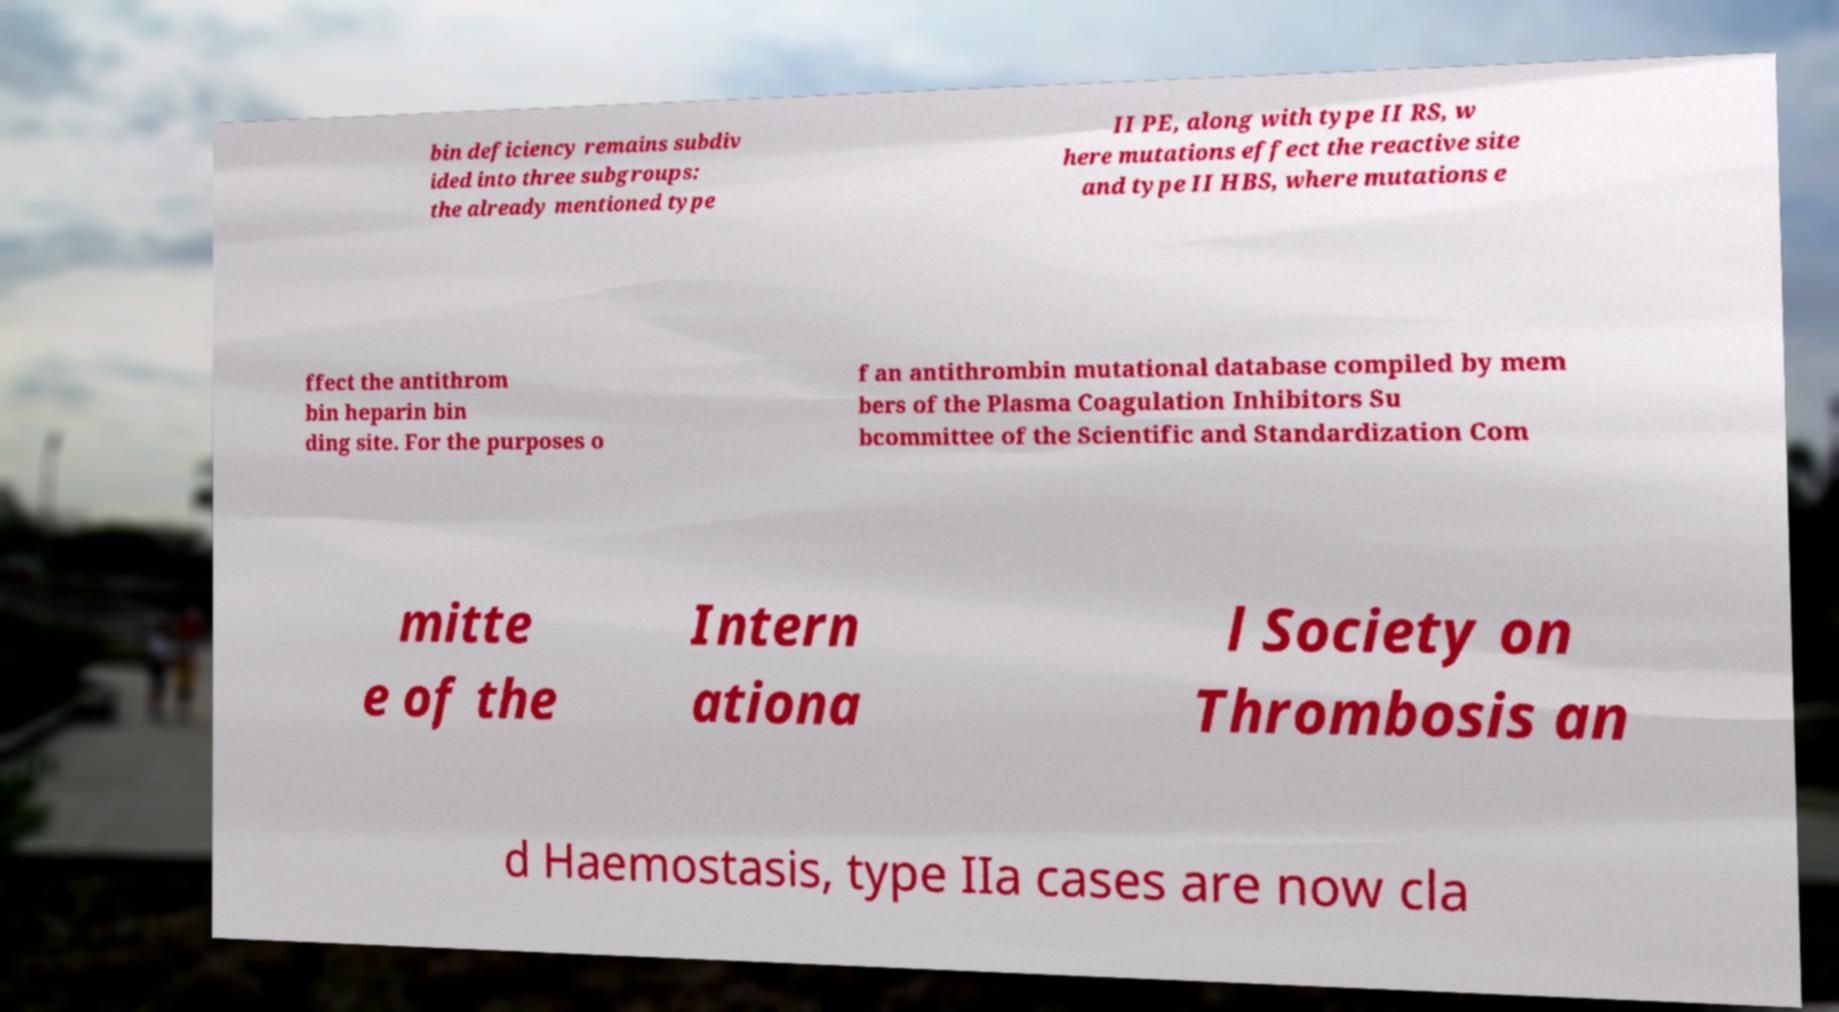Please read and relay the text visible in this image. What does it say? bin deficiency remains subdiv ided into three subgroups: the already mentioned type II PE, along with type II RS, w here mutations effect the reactive site and type II HBS, where mutations e ffect the antithrom bin heparin bin ding site. For the purposes o f an antithrombin mutational database compiled by mem bers of the Plasma Coagulation Inhibitors Su bcommittee of the Scientific and Standardization Com mitte e of the Intern ationa l Society on Thrombosis an d Haemostasis, type IIa cases are now cla 